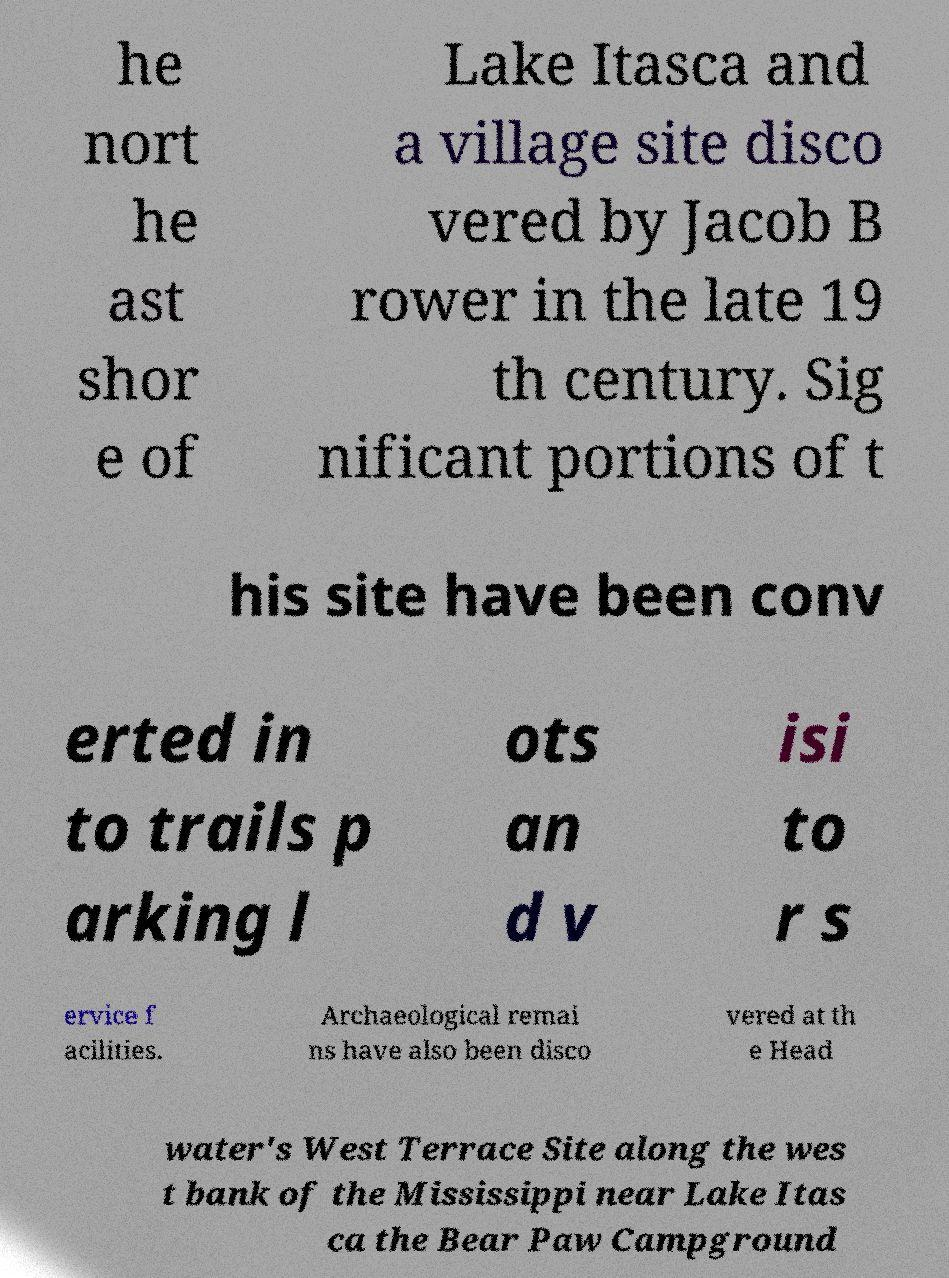What messages or text are displayed in this image? I need them in a readable, typed format. he nort he ast shor e of Lake Itasca and a village site disco vered by Jacob B rower in the late 19 th century. Sig nificant portions of t his site have been conv erted in to trails p arking l ots an d v isi to r s ervice f acilities. Archaeological remai ns have also been disco vered at th e Head water's West Terrace Site along the wes t bank of the Mississippi near Lake Itas ca the Bear Paw Campground 